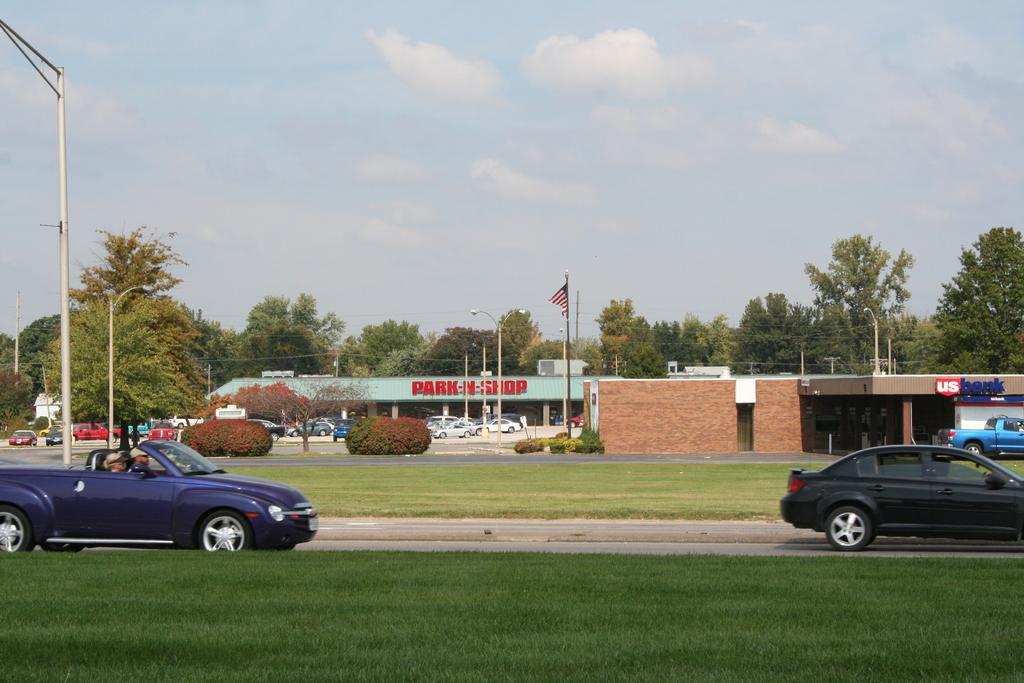Please provide a concise description of this image. In this image there are cars on road, in the background there is garden, trees poles cars and ships and there is a sky. 